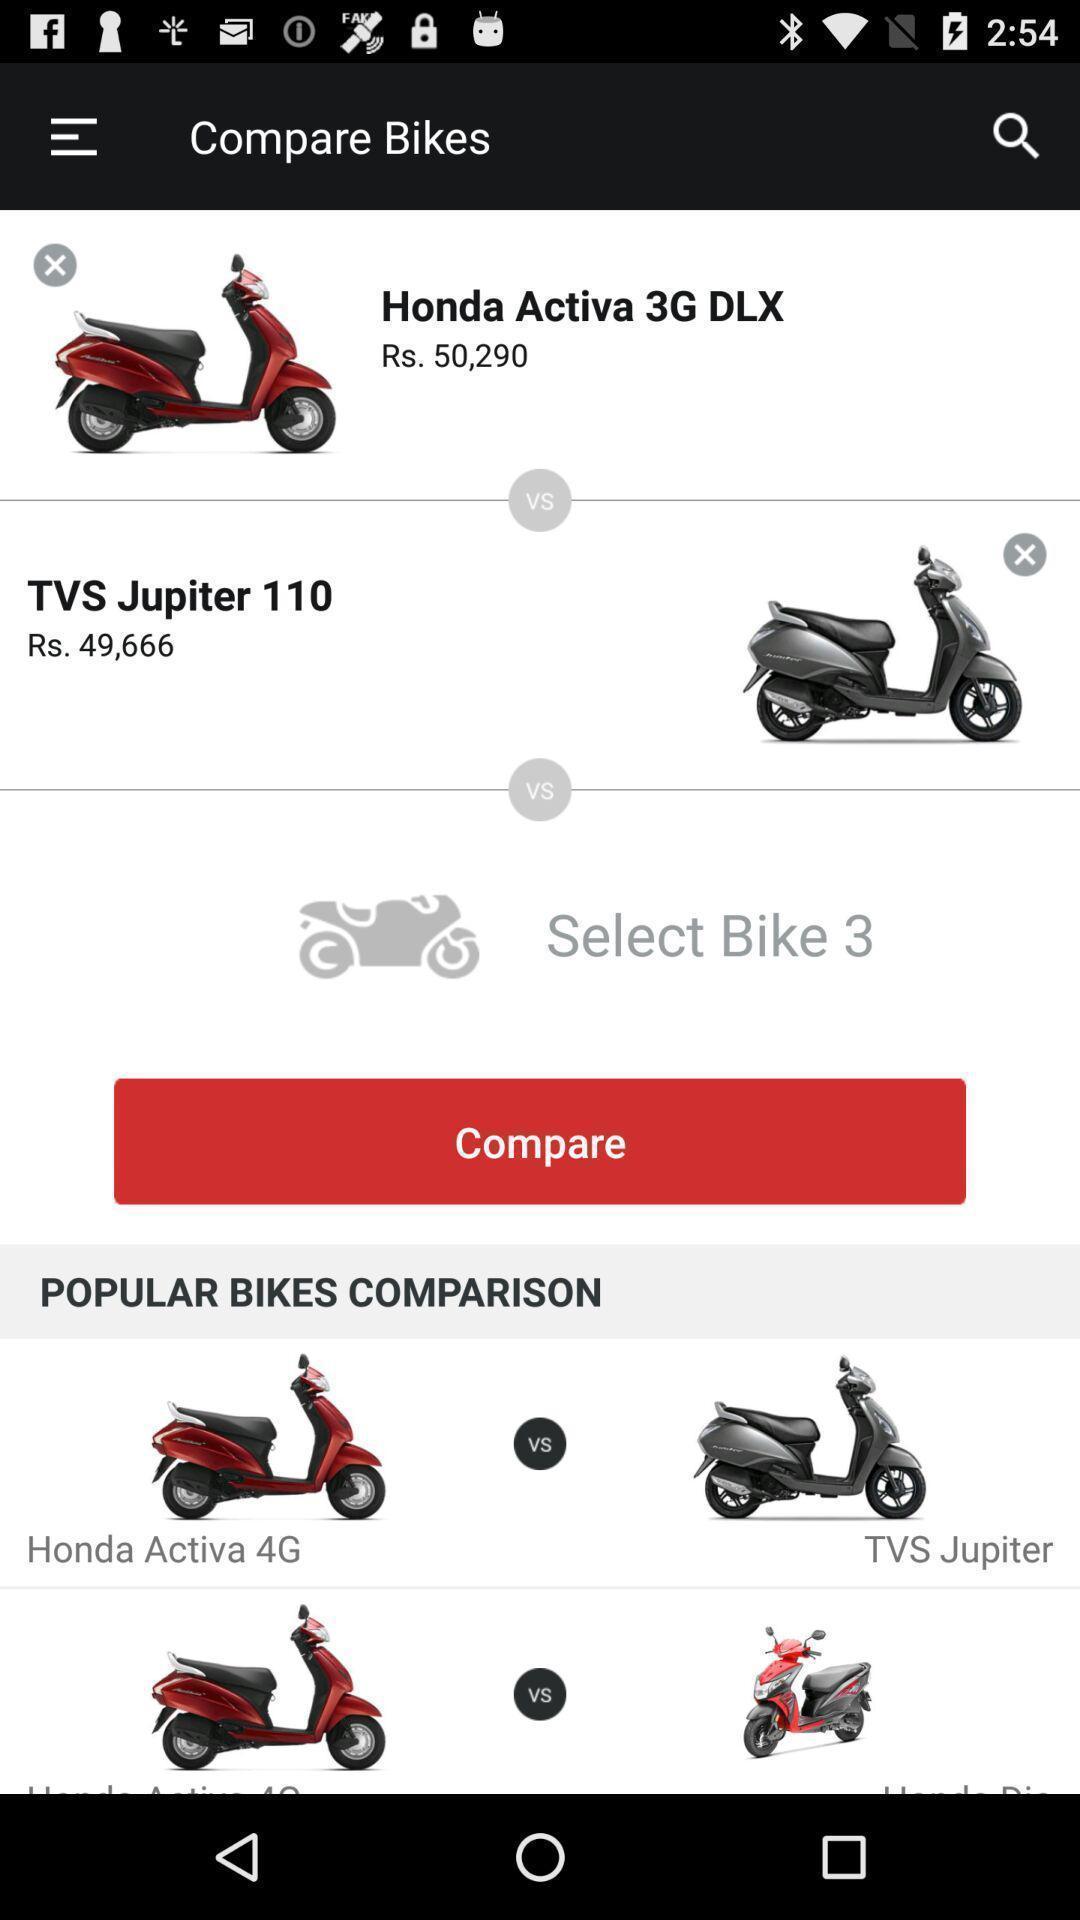Describe this image in words. Page showing the different images of bikes with price. 